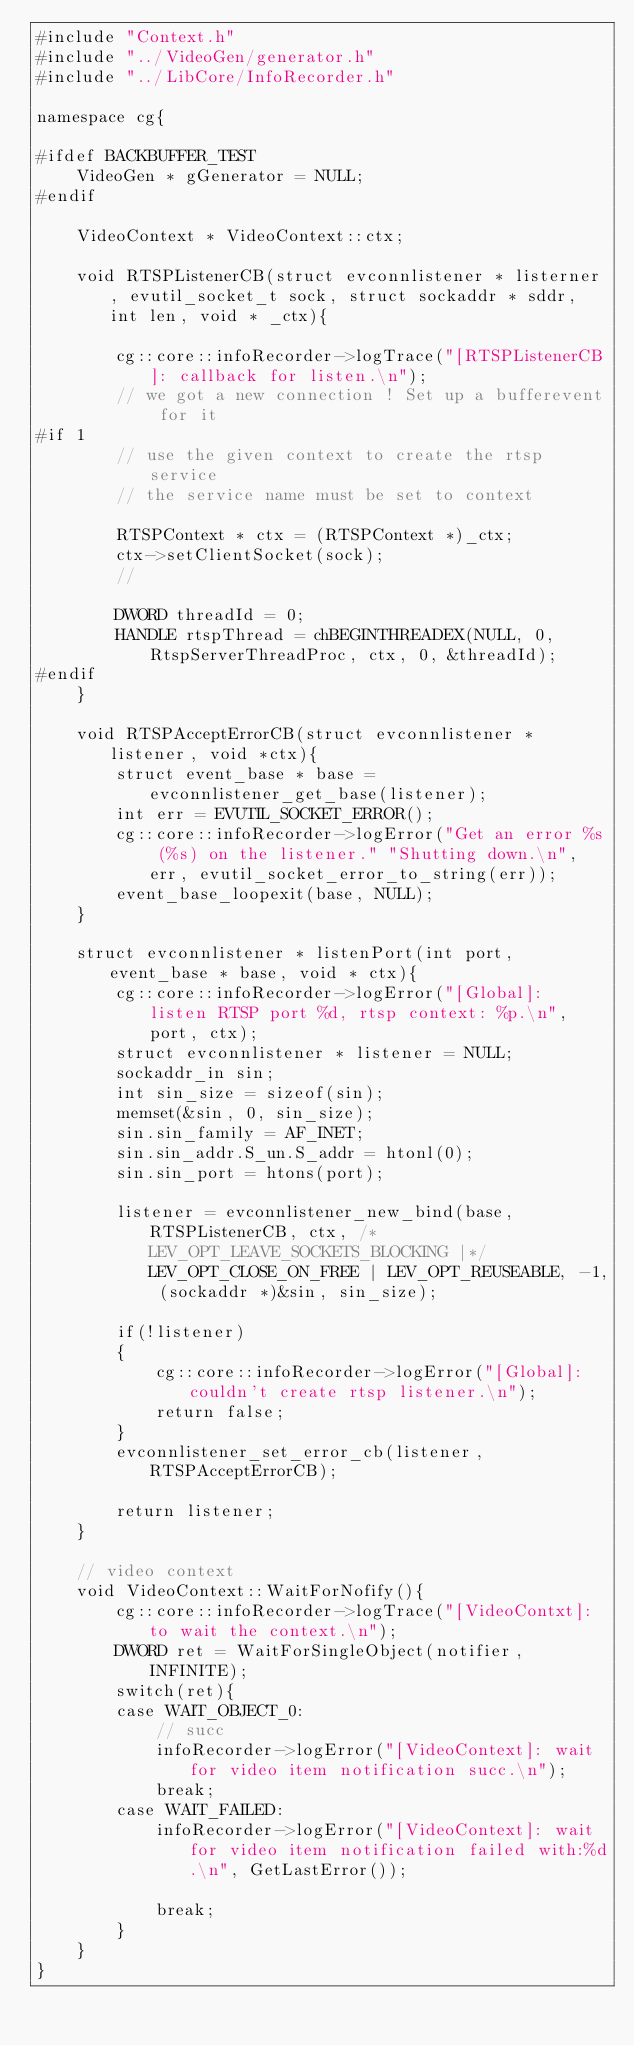Convert code to text. <code><loc_0><loc_0><loc_500><loc_500><_C++_>#include "Context.h"
#include "../VideoGen/generator.h"
#include "../LibCore/InfoRecorder.h"

namespace cg{

#ifdef BACKBUFFER_TEST
	VideoGen * gGenerator = NULL;
#endif

	VideoContext * VideoContext::ctx;

	void RTSPListenerCB(struct evconnlistener * listerner, evutil_socket_t sock, struct sockaddr * sddr, int len, void * _ctx){

		cg::core::infoRecorder->logTrace("[RTSPListenerCB]: callback for listen.\n");
		// we got a new connection ! Set up a bufferevent for it
#if 1
		// use the given context to create the rtsp service
		// the service name must be set to context

		RTSPContext * ctx = (RTSPContext *)_ctx;
		ctx->setClientSocket(sock);
		//
		
		DWORD threadId = 0;
		HANDLE rtspThread = chBEGINTHREADEX(NULL, 0, RtspServerThreadProc, ctx, 0, &threadId);
#endif
	}

	void RTSPAcceptErrorCB(struct evconnlistener * listener, void *ctx){
		struct event_base * base = evconnlistener_get_base(listener);
		int err = EVUTIL_SOCKET_ERROR();
		cg::core::infoRecorder->logError("Get an error %s (%s) on the listener." "Shutting down.\n", err, evutil_socket_error_to_string(err));
		event_base_loopexit(base, NULL);
	}

	struct evconnlistener * listenPort(int port, event_base * base, void * ctx){
		cg::core::infoRecorder->logError("[Global]: listen RTSP port %d, rtsp context: %p.\n", port, ctx);
		struct evconnlistener * listener = NULL;
		sockaddr_in sin;
		int sin_size = sizeof(sin);
		memset(&sin, 0, sin_size);
		sin.sin_family = AF_INET;
		sin.sin_addr.S_un.S_addr = htonl(0);
		sin.sin_port = htons(port);

		listener = evconnlistener_new_bind(base, RTSPListenerCB, ctx, /*LEV_OPT_LEAVE_SOCKETS_BLOCKING |*/ LEV_OPT_CLOSE_ON_FREE | LEV_OPT_REUSEABLE, -1, (sockaddr *)&sin, sin_size);

		if(!listener)
		{
			cg::core::infoRecorder->logError("[Global]: couldn't create rtsp listener.\n");
			return false;
		}
		evconnlistener_set_error_cb(listener, RTSPAcceptErrorCB);

		return listener;
	}

	// video context
	void VideoContext::WaitForNofify(){
		cg::core::infoRecorder->logTrace("[VideoContxt]: to wait the context.\n");
		DWORD ret = WaitForSingleObject(notifier, INFINITE);
		switch(ret){
		case WAIT_OBJECT_0:
			// succ
			infoRecorder->logError("[VideoContext]: wait for video item notification succ.\n");
			break;
		case WAIT_FAILED:
			infoRecorder->logError("[VideoContext]: wait for video item notification failed with:%d.\n", GetLastError());

			break;
		}
	}
}</code> 